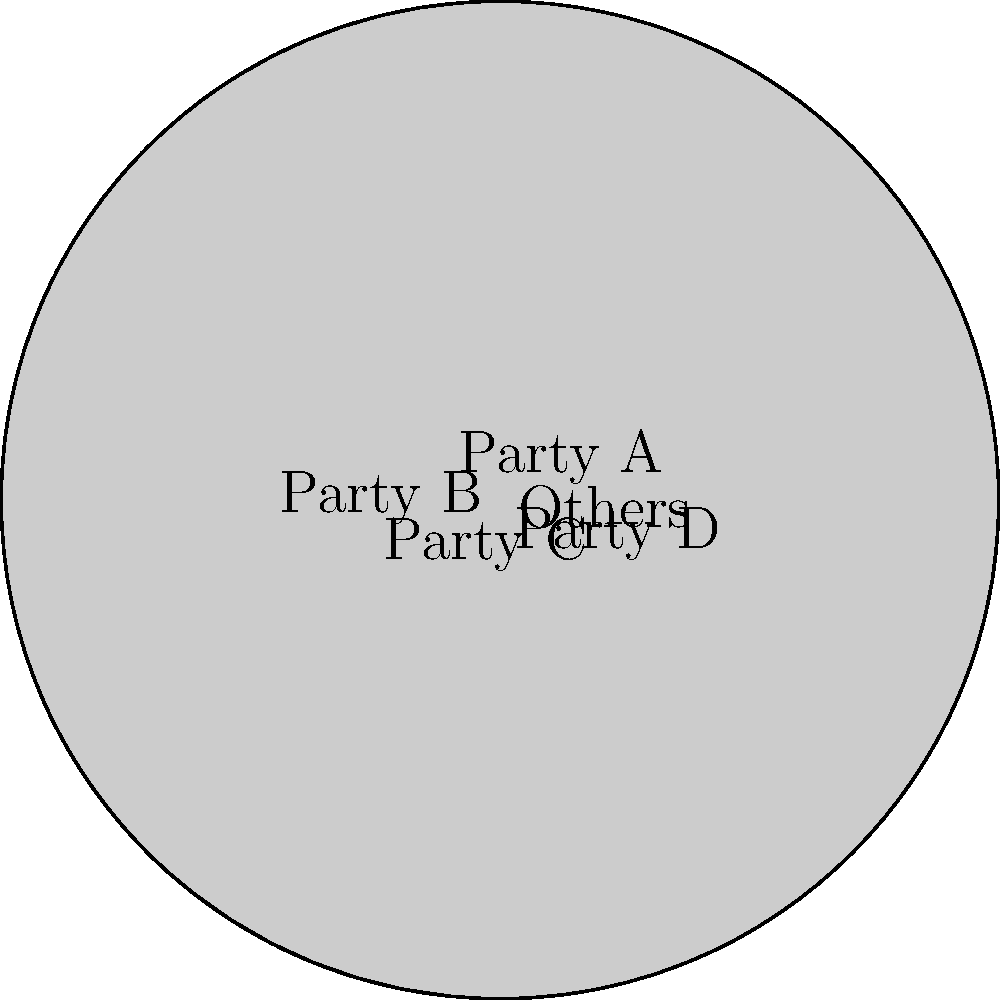As an event planner organizing a discussion on regional politics, you're presented with the following pie chart showing the distribution of seats in a regional parliament. If the total number of seats is 200, how many seats does Party C hold? To solve this problem, we need to follow these steps:

1. Identify the percentage of seats held by Party C from the pie chart.
   Party C holds 20% of the seats.

2. Calculate the number of seats based on the given total and percentage:
   - Total seats = 200
   - Party C's percentage = 20%

3. Use the formula: Number of seats = (Percentage / 100) × Total seats
   $\text{Number of seats} = \frac{20}{100} \times 200$

4. Perform the calculation:
   $\text{Number of seats} = 0.2 \times 200 = 40$

Therefore, Party C holds 40 seats in the regional parliament.
Answer: 40 seats 